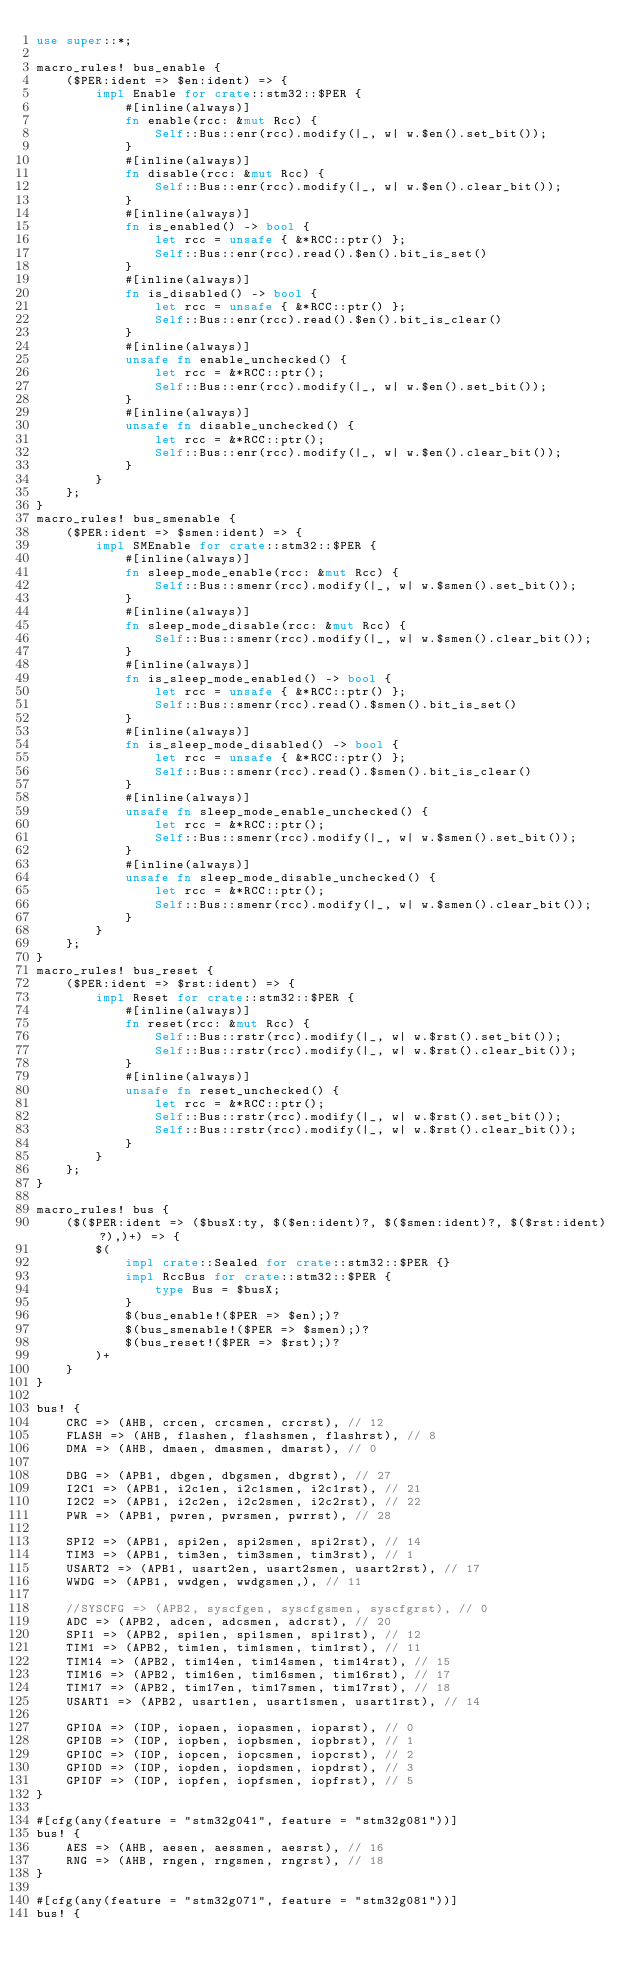Convert code to text. <code><loc_0><loc_0><loc_500><loc_500><_Rust_>use super::*;

macro_rules! bus_enable {
    ($PER:ident => $en:ident) => {
        impl Enable for crate::stm32::$PER {
            #[inline(always)]
            fn enable(rcc: &mut Rcc) {
                Self::Bus::enr(rcc).modify(|_, w| w.$en().set_bit());
            }
            #[inline(always)]
            fn disable(rcc: &mut Rcc) {
                Self::Bus::enr(rcc).modify(|_, w| w.$en().clear_bit());
            }
            #[inline(always)]
            fn is_enabled() -> bool {
                let rcc = unsafe { &*RCC::ptr() };
                Self::Bus::enr(rcc).read().$en().bit_is_set()
            }
            #[inline(always)]
            fn is_disabled() -> bool {
                let rcc = unsafe { &*RCC::ptr() };
                Self::Bus::enr(rcc).read().$en().bit_is_clear()
            }
            #[inline(always)]
            unsafe fn enable_unchecked() {
                let rcc = &*RCC::ptr();
                Self::Bus::enr(rcc).modify(|_, w| w.$en().set_bit());
            }
            #[inline(always)]
            unsafe fn disable_unchecked() {
                let rcc = &*RCC::ptr();
                Self::Bus::enr(rcc).modify(|_, w| w.$en().clear_bit());
            }
        }
    };
}
macro_rules! bus_smenable {
    ($PER:ident => $smen:ident) => {
        impl SMEnable for crate::stm32::$PER {
            #[inline(always)]
            fn sleep_mode_enable(rcc: &mut Rcc) {
                Self::Bus::smenr(rcc).modify(|_, w| w.$smen().set_bit());
            }
            #[inline(always)]
            fn sleep_mode_disable(rcc: &mut Rcc) {
                Self::Bus::smenr(rcc).modify(|_, w| w.$smen().clear_bit());
            }
            #[inline(always)]
            fn is_sleep_mode_enabled() -> bool {
                let rcc = unsafe { &*RCC::ptr() };
                Self::Bus::smenr(rcc).read().$smen().bit_is_set()
            }
            #[inline(always)]
            fn is_sleep_mode_disabled() -> bool {
                let rcc = unsafe { &*RCC::ptr() };
                Self::Bus::smenr(rcc).read().$smen().bit_is_clear()
            }
            #[inline(always)]
            unsafe fn sleep_mode_enable_unchecked() {
                let rcc = &*RCC::ptr();
                Self::Bus::smenr(rcc).modify(|_, w| w.$smen().set_bit());
            }
            #[inline(always)]
            unsafe fn sleep_mode_disable_unchecked() {
                let rcc = &*RCC::ptr();
                Self::Bus::smenr(rcc).modify(|_, w| w.$smen().clear_bit());
            }
        }
    };
}
macro_rules! bus_reset {
    ($PER:ident => $rst:ident) => {
        impl Reset for crate::stm32::$PER {
            #[inline(always)]
            fn reset(rcc: &mut Rcc) {
                Self::Bus::rstr(rcc).modify(|_, w| w.$rst().set_bit());
                Self::Bus::rstr(rcc).modify(|_, w| w.$rst().clear_bit());
            }
            #[inline(always)]
            unsafe fn reset_unchecked() {
                let rcc = &*RCC::ptr();
                Self::Bus::rstr(rcc).modify(|_, w| w.$rst().set_bit());
                Self::Bus::rstr(rcc).modify(|_, w| w.$rst().clear_bit());
            }
        }
    };
}

macro_rules! bus {
    ($($PER:ident => ($busX:ty, $($en:ident)?, $($smen:ident)?, $($rst:ident)?),)+) => {
        $(
            impl crate::Sealed for crate::stm32::$PER {}
            impl RccBus for crate::stm32::$PER {
                type Bus = $busX;
            }
            $(bus_enable!($PER => $en);)?
            $(bus_smenable!($PER => $smen);)?
            $(bus_reset!($PER => $rst);)?
        )+
    }
}

bus! {
    CRC => (AHB, crcen, crcsmen, crcrst), // 12
    FLASH => (AHB, flashen, flashsmen, flashrst), // 8
    DMA => (AHB, dmaen, dmasmen, dmarst), // 0

    DBG => (APB1, dbgen, dbgsmen, dbgrst), // 27
    I2C1 => (APB1, i2c1en, i2c1smen, i2c1rst), // 21
    I2C2 => (APB1, i2c2en, i2c2smen, i2c2rst), // 22
    PWR => (APB1, pwren, pwrsmen, pwrrst), // 28

    SPI2 => (APB1, spi2en, spi2smen, spi2rst), // 14
    TIM3 => (APB1, tim3en, tim3smen, tim3rst), // 1
    USART2 => (APB1, usart2en, usart2smen, usart2rst), // 17
    WWDG => (APB1, wwdgen, wwdgsmen,), // 11

    //SYSCFG => (APB2, syscfgen, syscfgsmen, syscfgrst), // 0
    ADC => (APB2, adcen, adcsmen, adcrst), // 20
    SPI1 => (APB2, spi1en, spi1smen, spi1rst), // 12
    TIM1 => (APB2, tim1en, tim1smen, tim1rst), // 11
    TIM14 => (APB2, tim14en, tim14smen, tim14rst), // 15
    TIM16 => (APB2, tim16en, tim16smen, tim16rst), // 17
    TIM17 => (APB2, tim17en, tim17smen, tim17rst), // 18
    USART1 => (APB2, usart1en, usart1smen, usart1rst), // 14

    GPIOA => (IOP, iopaen, iopasmen, ioparst), // 0
    GPIOB => (IOP, iopben, iopbsmen, iopbrst), // 1
    GPIOC => (IOP, iopcen, iopcsmen, iopcrst), // 2
    GPIOD => (IOP, iopden, iopdsmen, iopdrst), // 3
    GPIOF => (IOP, iopfen, iopfsmen, iopfrst), // 5
}

#[cfg(any(feature = "stm32g041", feature = "stm32g081"))]
bus! {
    AES => (AHB, aesen, aessmen, aesrst), // 16
    RNG => (AHB, rngen, rngsmen, rngrst), // 18
}

#[cfg(any(feature = "stm32g071", feature = "stm32g081"))]
bus! {</code> 